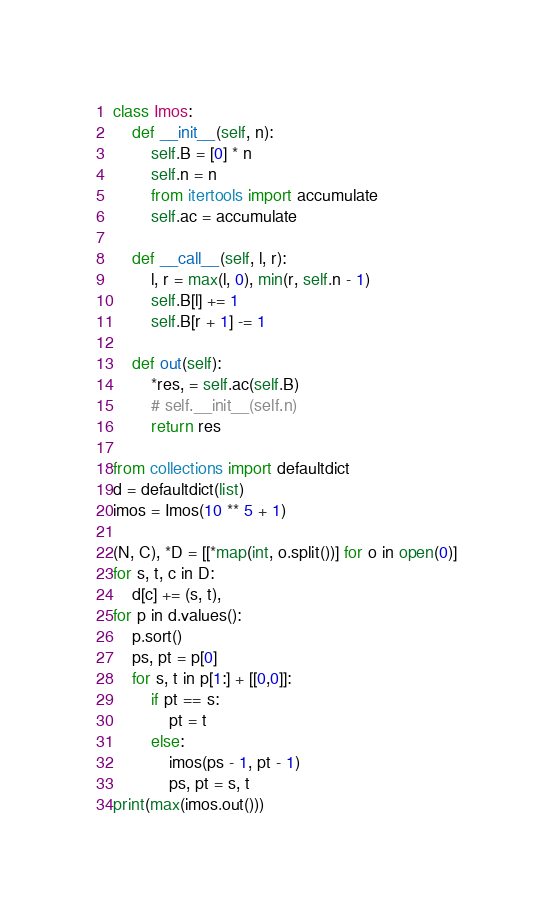<code> <loc_0><loc_0><loc_500><loc_500><_Python_>class Imos:
    def __init__(self, n):
        self.B = [0] * n
        self.n = n
        from itertools import accumulate
        self.ac = accumulate

    def __call__(self, l, r):
        l, r = max(l, 0), min(r, self.n - 1)
        self.B[l] += 1
        self.B[r + 1] -= 1

    def out(self):
        *res, = self.ac(self.B)
        # self.__init__(self.n)
        return res

from collections import defaultdict
d = defaultdict(list)
imos = Imos(10 ** 5 + 1)

(N, C), *D = [[*map(int, o.split())] for o in open(0)]
for s, t, c in D:
    d[c] += (s, t),
for p in d.values():
    p.sort()
    ps, pt = p[0]
    for s, t in p[1:] + [[0,0]]:
        if pt == s:
            pt = t
        else:
            imos(ps - 1, pt - 1)
            ps, pt = s, t
print(max(imos.out()))</code> 